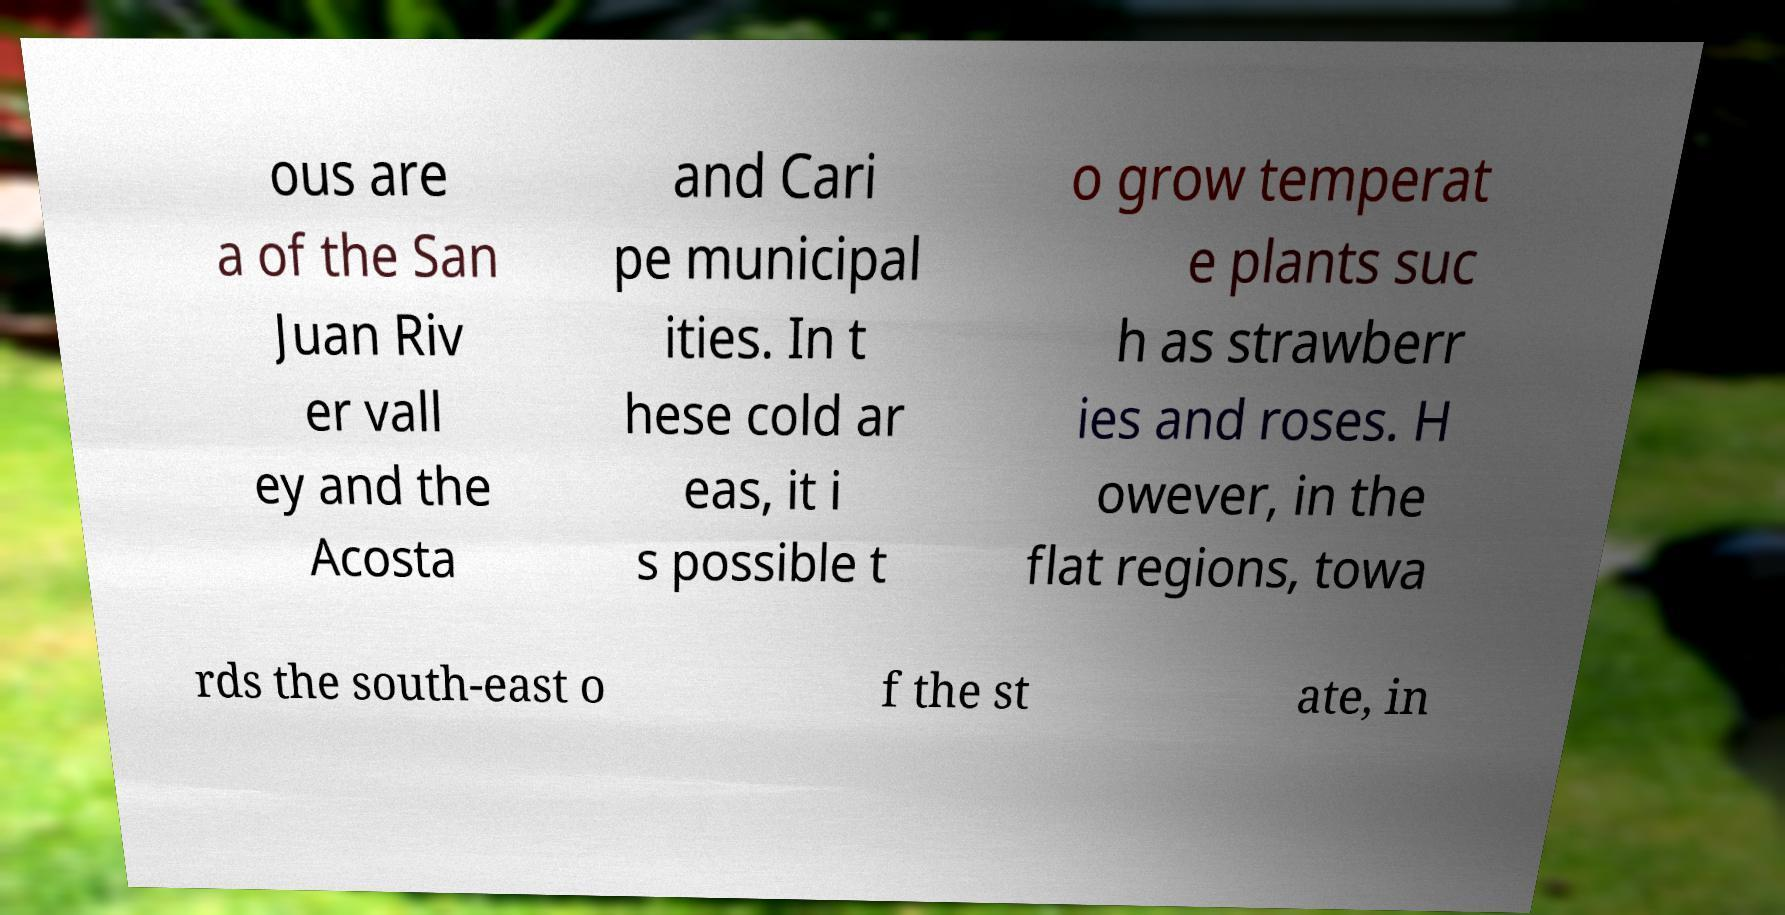Can you read and provide the text displayed in the image?This photo seems to have some interesting text. Can you extract and type it out for me? ous are a of the San Juan Riv er vall ey and the Acosta and Cari pe municipal ities. In t hese cold ar eas, it i s possible t o grow temperat e plants suc h as strawberr ies and roses. H owever, in the flat regions, towa rds the south-east o f the st ate, in 